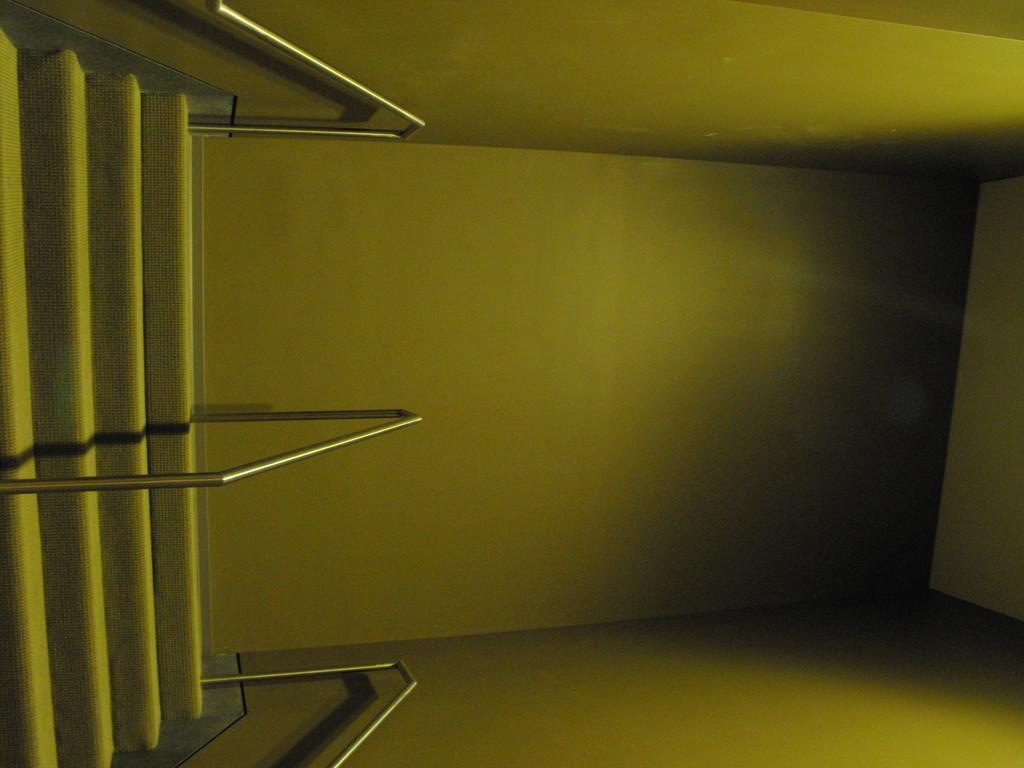Describe this image in one or two sentences. On the left side of the image, we can see stairs and rod railings. Here we can see the walls. 